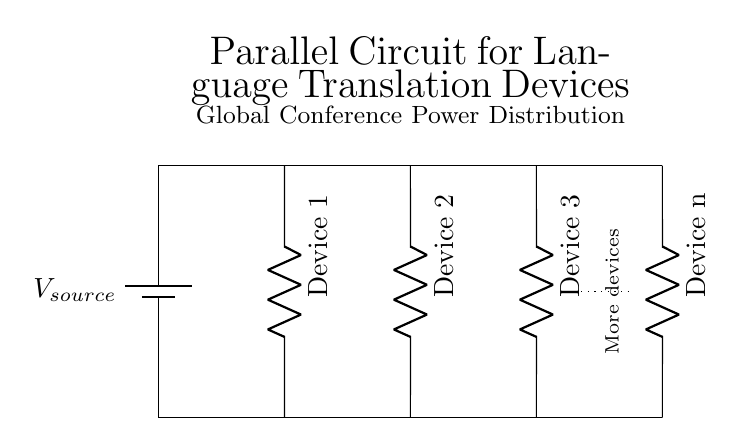What type of circuit is shown? The circuit is a parallel circuit because the devices are connected across the same two points, allowing each device to operate independently.
Answer: Parallel How many devices are in the circuit diagram? There are three specific devices labeled from one to three plus an indication of additional devices, leading to a total of at least four devices.
Answer: Four What is the purpose of the battery in this circuit? The battery serves as a power source providing voltage to the circuit, ensuring that all connected devices receive the necessary electrical energy to function.
Answer: Power source How does the failure of one device affect the others in this circuit? In a parallel circuit, if one device fails, it does not affect the operation of the other devices since each device has its own independent path to the power source.
Answer: No effect What does the dotted line represent in the diagram? The dotted line indicates the possibility of connecting more devices, suggesting scalability or flexibility in the circuit layout for additional translation devices.
Answer: More devices 